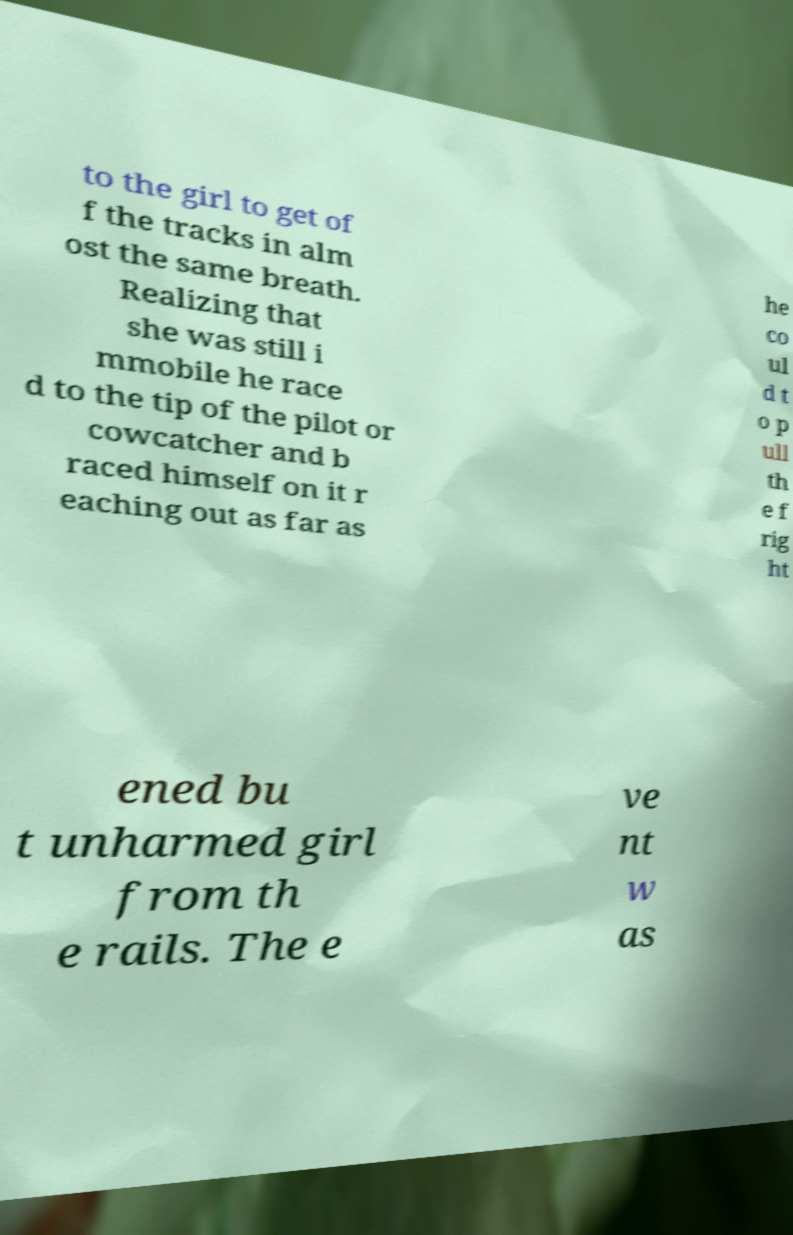There's text embedded in this image that I need extracted. Can you transcribe it verbatim? to the girl to get of f the tracks in alm ost the same breath. Realizing that she was still i mmobile he race d to the tip of the pilot or cowcatcher and b raced himself on it r eaching out as far as he co ul d t o p ull th e f rig ht ened bu t unharmed girl from th e rails. The e ve nt w as 